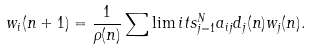Convert formula to latex. <formula><loc_0><loc_0><loc_500><loc_500>w _ { i } ( n + 1 ) = \frac { 1 } { \rho ( n ) } \sum \lim i t s _ { j = 1 } ^ { N } a _ { i j } d _ { j } ( n ) w _ { j } ( n ) .</formula> 